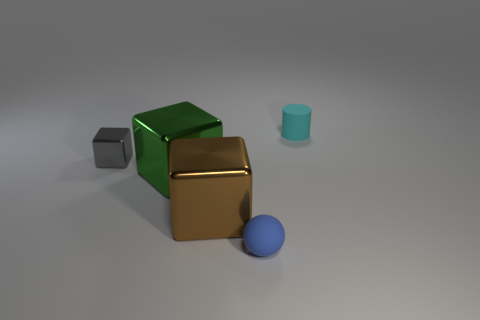What is the color of the matte object that is in front of the cyan cylinder? The matte object in front of the cyan cylinder is the gray cube. 